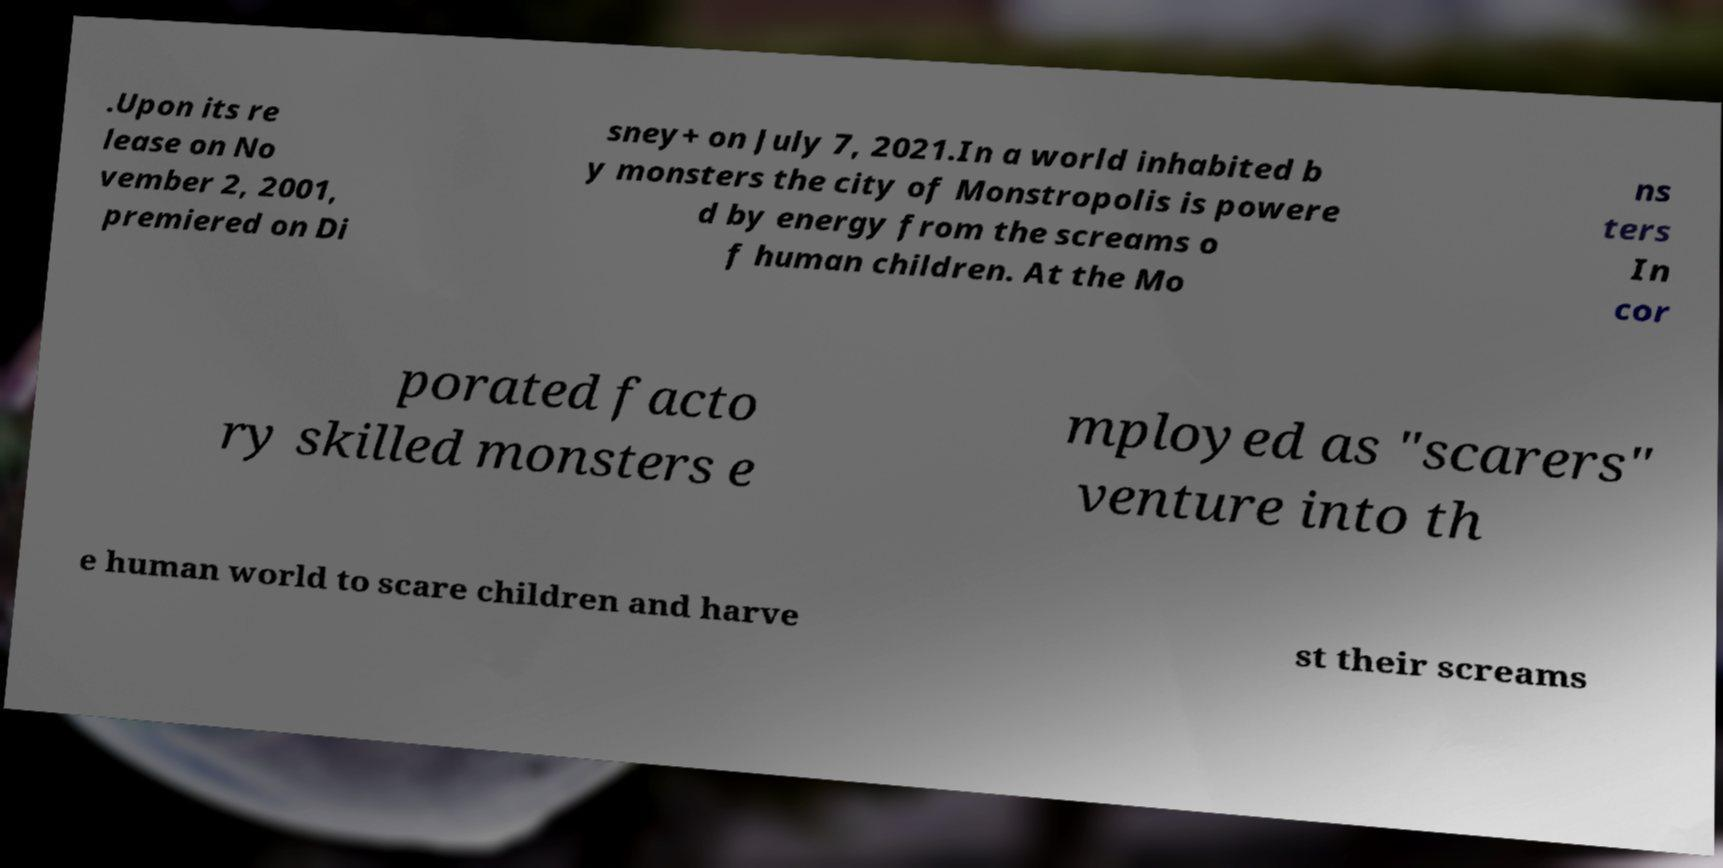Can you accurately transcribe the text from the provided image for me? .Upon its re lease on No vember 2, 2001, premiered on Di sney+ on July 7, 2021.In a world inhabited b y monsters the city of Monstropolis is powere d by energy from the screams o f human children. At the Mo ns ters In cor porated facto ry skilled monsters e mployed as "scarers" venture into th e human world to scare children and harve st their screams 